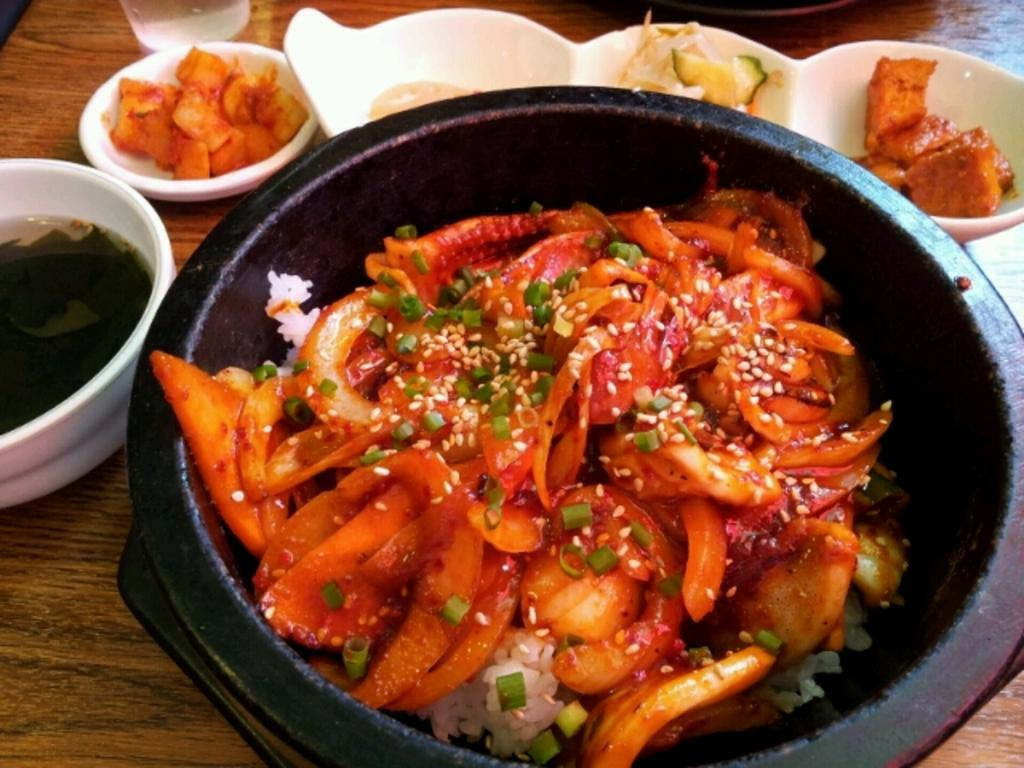What type of table is in the image? There is a wooden table in the image. What is on top of the table? There are bowls and a glass on the table. What is inside the bowls? The food includes soups, rice, spring onions, and onions. Can you describe the glass on the table? The glass is empty or contains a beverage. What is the income of the person who prepared the food in the image? There is no information about the income of the person who prepared the food in the image. How does the food in the image express hate towards a particular group? The food in the image does not express hate towards any group; it is simply a meal with various ingredients. 